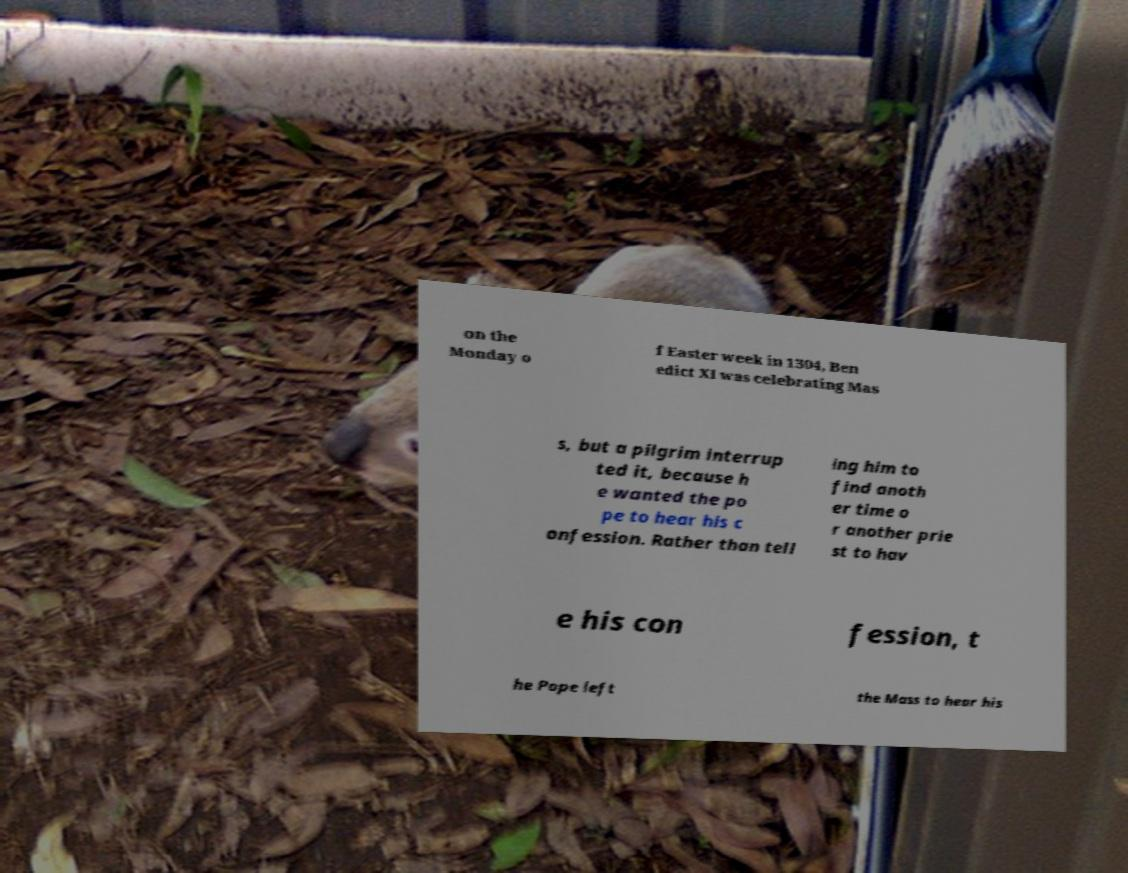What messages or text are displayed in this image? I need them in a readable, typed format. on the Monday o f Easter week in 1304, Ben edict XI was celebrating Mas s, but a pilgrim interrup ted it, because h e wanted the po pe to hear his c onfession. Rather than tell ing him to find anoth er time o r another prie st to hav e his con fession, t he Pope left the Mass to hear his 